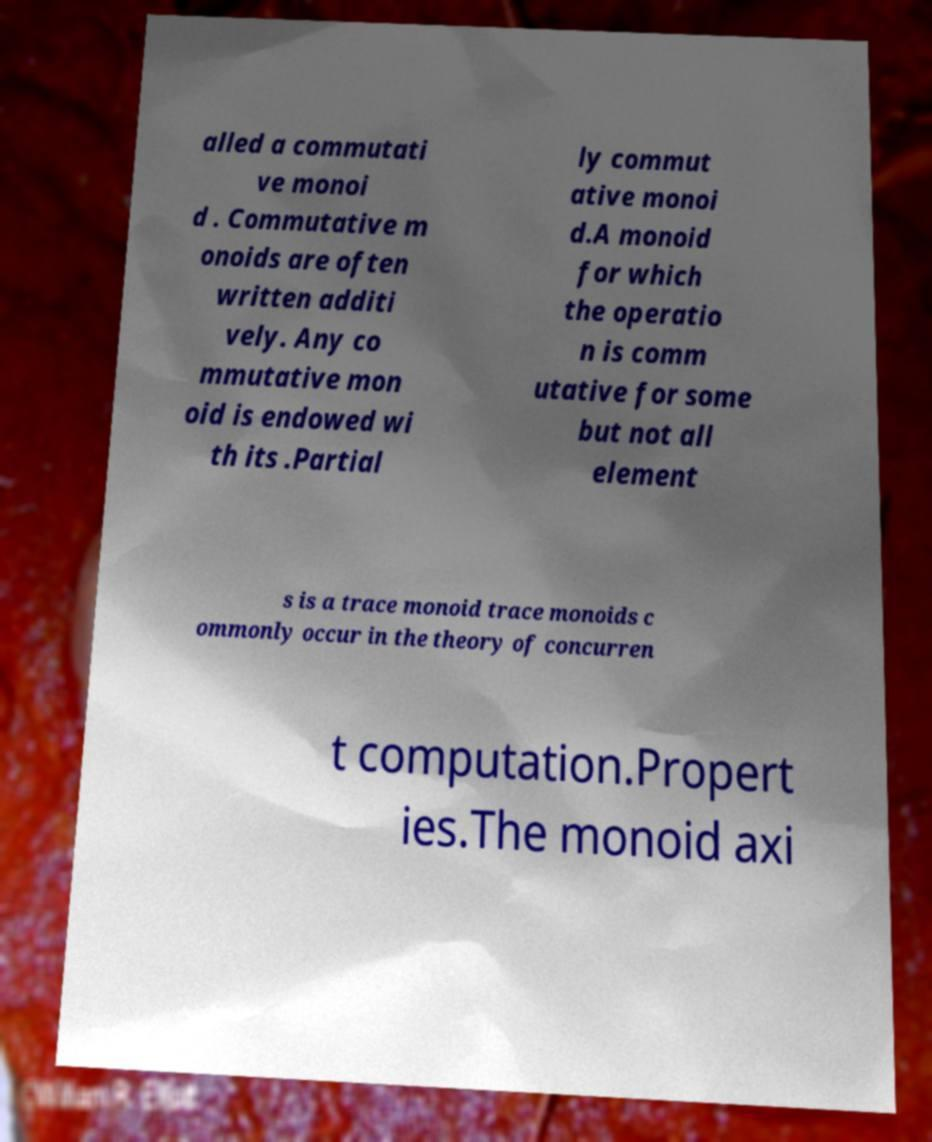What messages or text are displayed in this image? I need them in a readable, typed format. alled a commutati ve monoi d . Commutative m onoids are often written additi vely. Any co mmutative mon oid is endowed wi th its .Partial ly commut ative monoi d.A monoid for which the operatio n is comm utative for some but not all element s is a trace monoid trace monoids c ommonly occur in the theory of concurren t computation.Propert ies.The monoid axi 